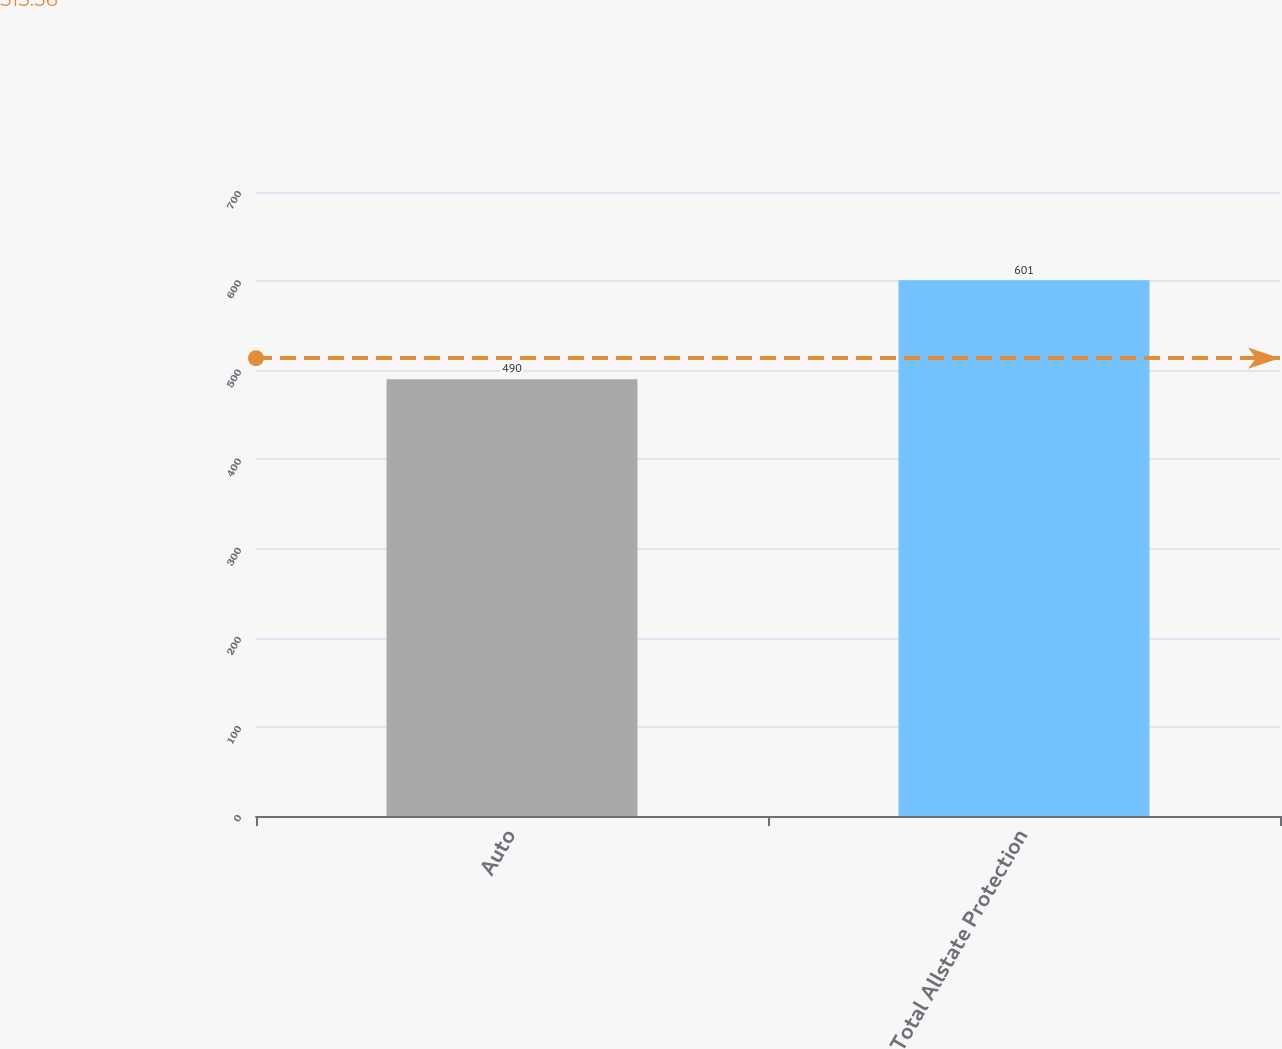Convert chart. <chart><loc_0><loc_0><loc_500><loc_500><bar_chart><fcel>Auto<fcel>Total Allstate Protection<nl><fcel>490<fcel>601<nl></chart> 